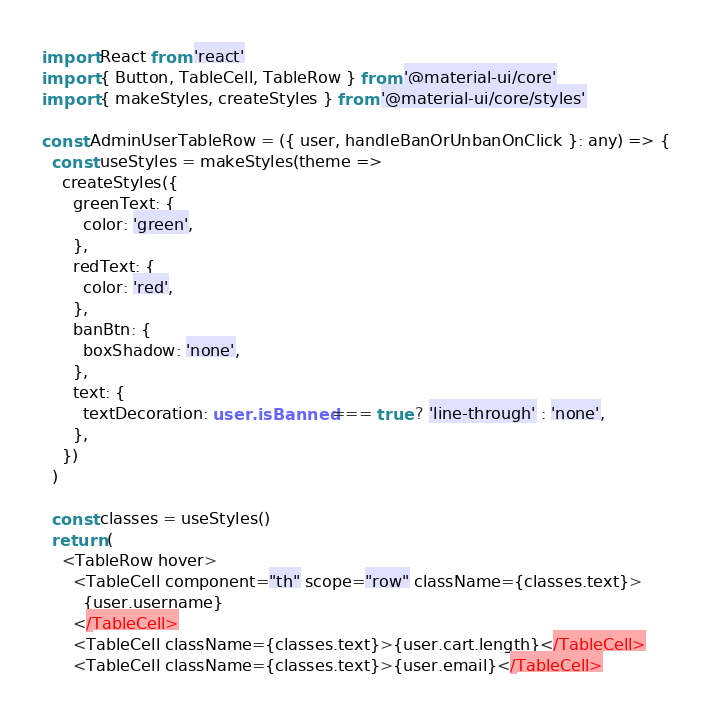Convert code to text. <code><loc_0><loc_0><loc_500><loc_500><_TypeScript_>import React from 'react'
import { Button, TableCell, TableRow } from '@material-ui/core'
import { makeStyles, createStyles } from '@material-ui/core/styles'

const AdminUserTableRow = ({ user, handleBanOrUnbanOnClick }: any) => {
  const useStyles = makeStyles(theme =>
    createStyles({
      greenText: {
        color: 'green',
      },
      redText: {
        color: 'red',
      },
      banBtn: {
        boxShadow: 'none',
      },
      text: {
        textDecoration: user.isBanned === true ? 'line-through' : 'none',
      },
    })
  )

  const classes = useStyles()
  return (
    <TableRow hover>
      <TableCell component="th" scope="row" className={classes.text}>
        {user.username}
      </TableCell>
      <TableCell className={classes.text}>{user.cart.length}</TableCell>
      <TableCell className={classes.text}>{user.email}</TableCell></code> 